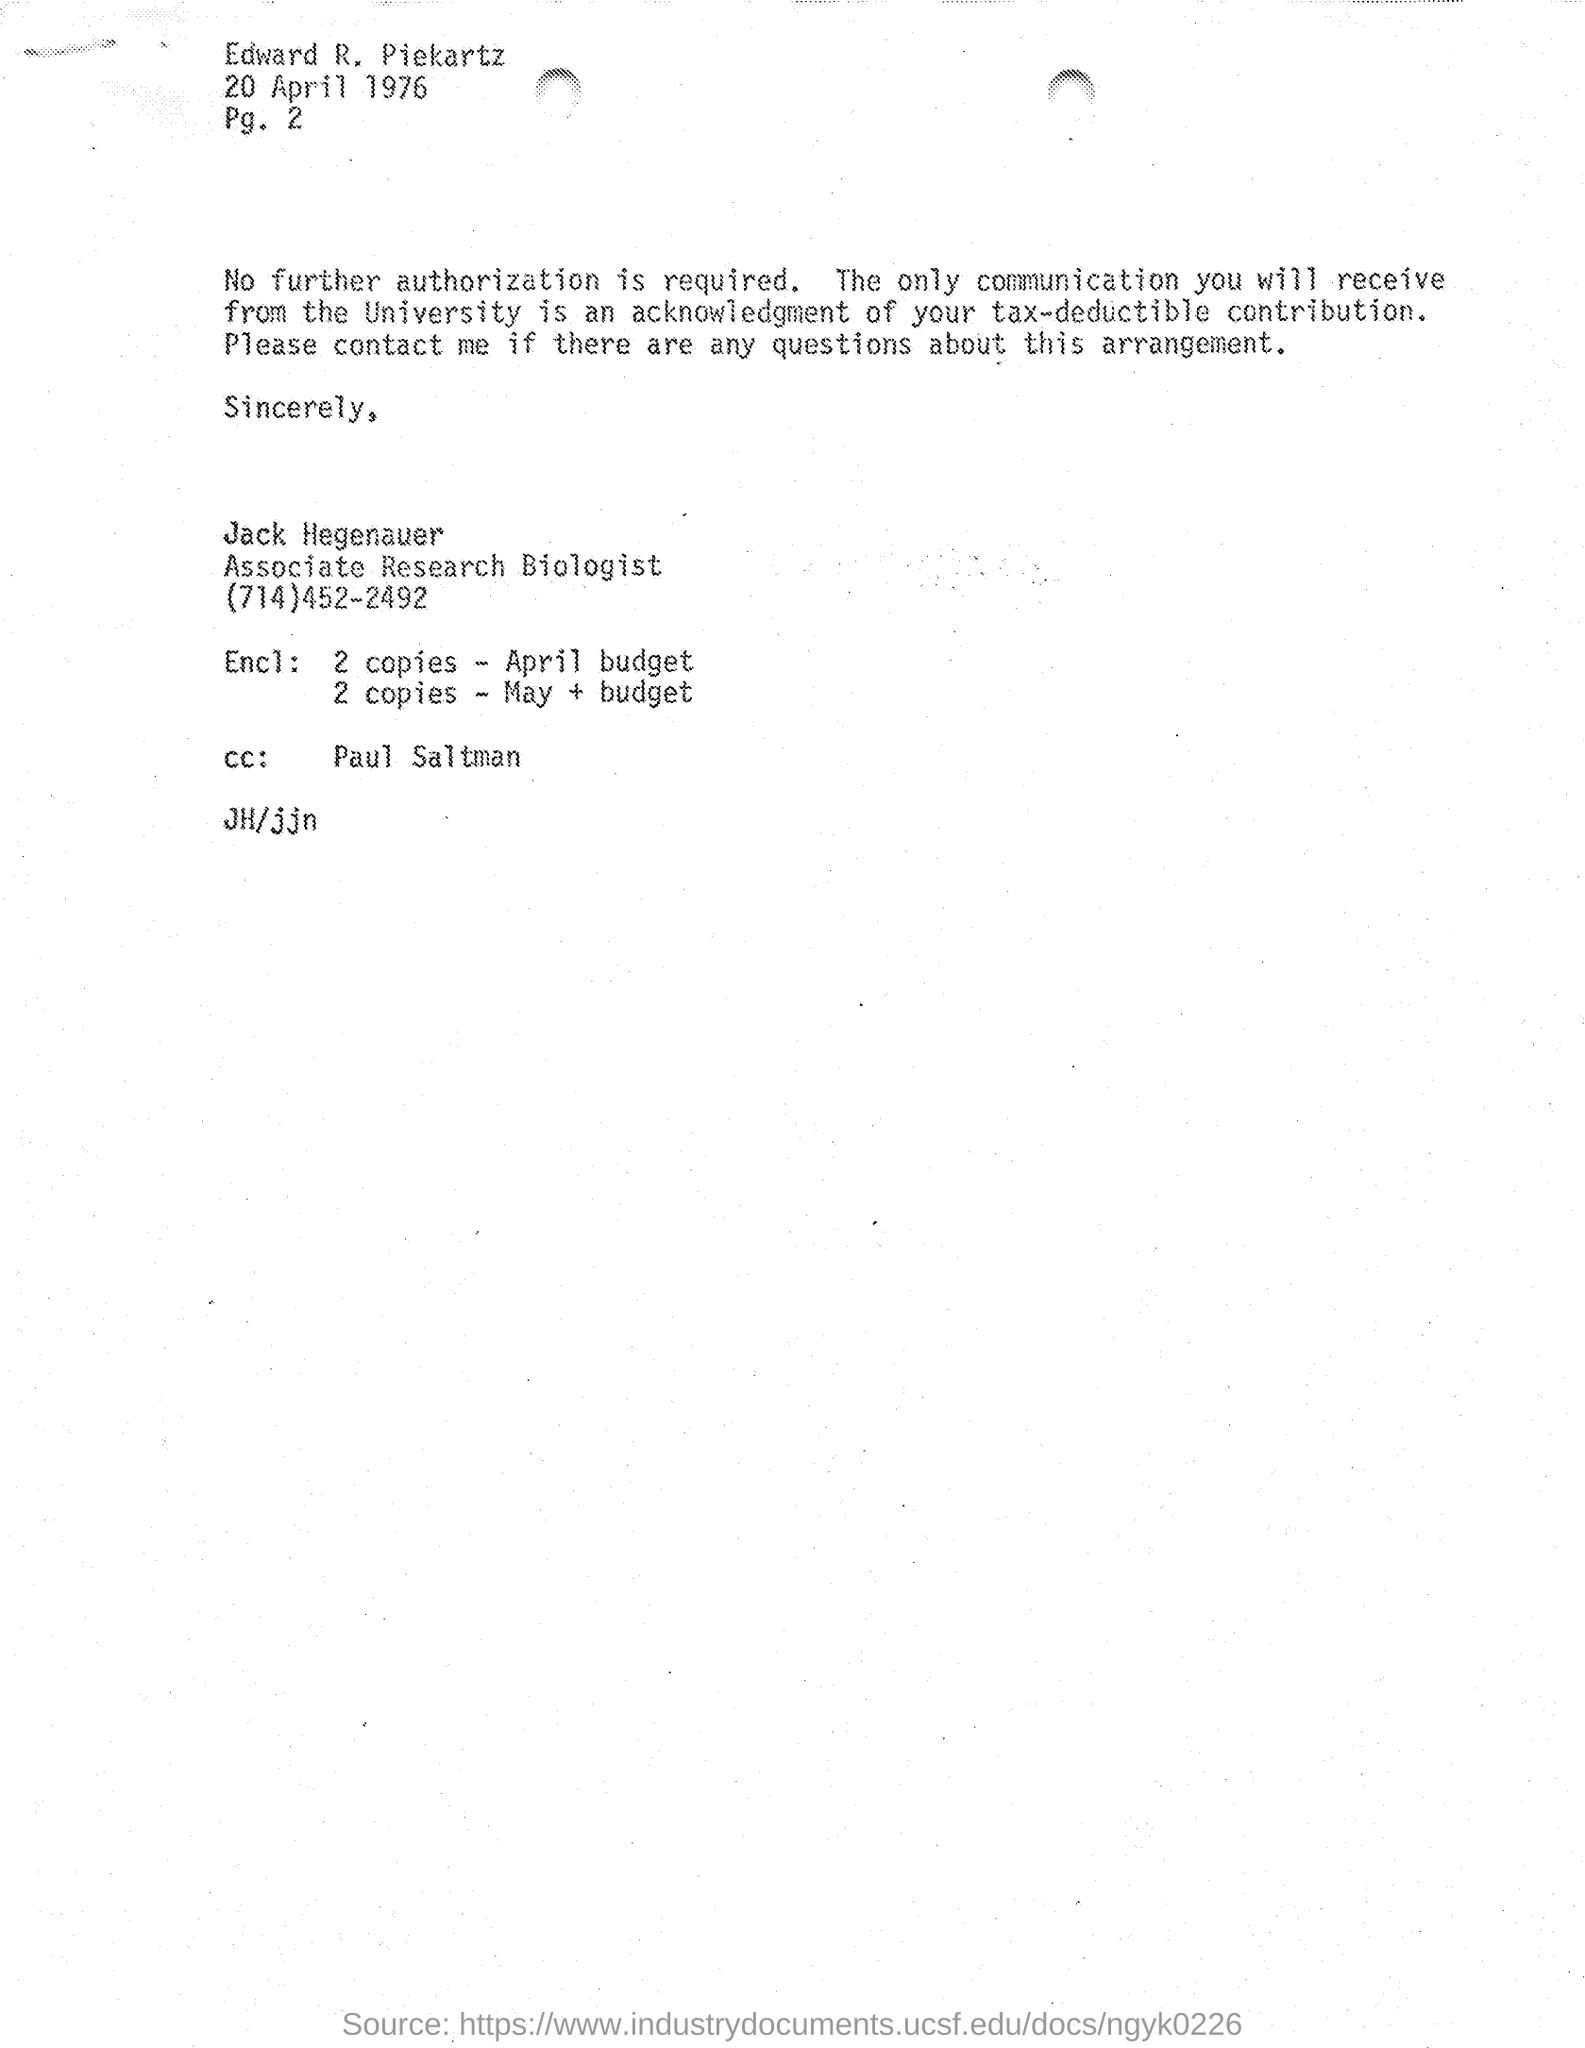To whom the CC is sent?
Your answer should be compact. Paul Saltman. Who wrote this letter?
Ensure brevity in your answer.  Jack Hegenauer. 